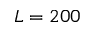<formula> <loc_0><loc_0><loc_500><loc_500>L = 2 0 0</formula> 